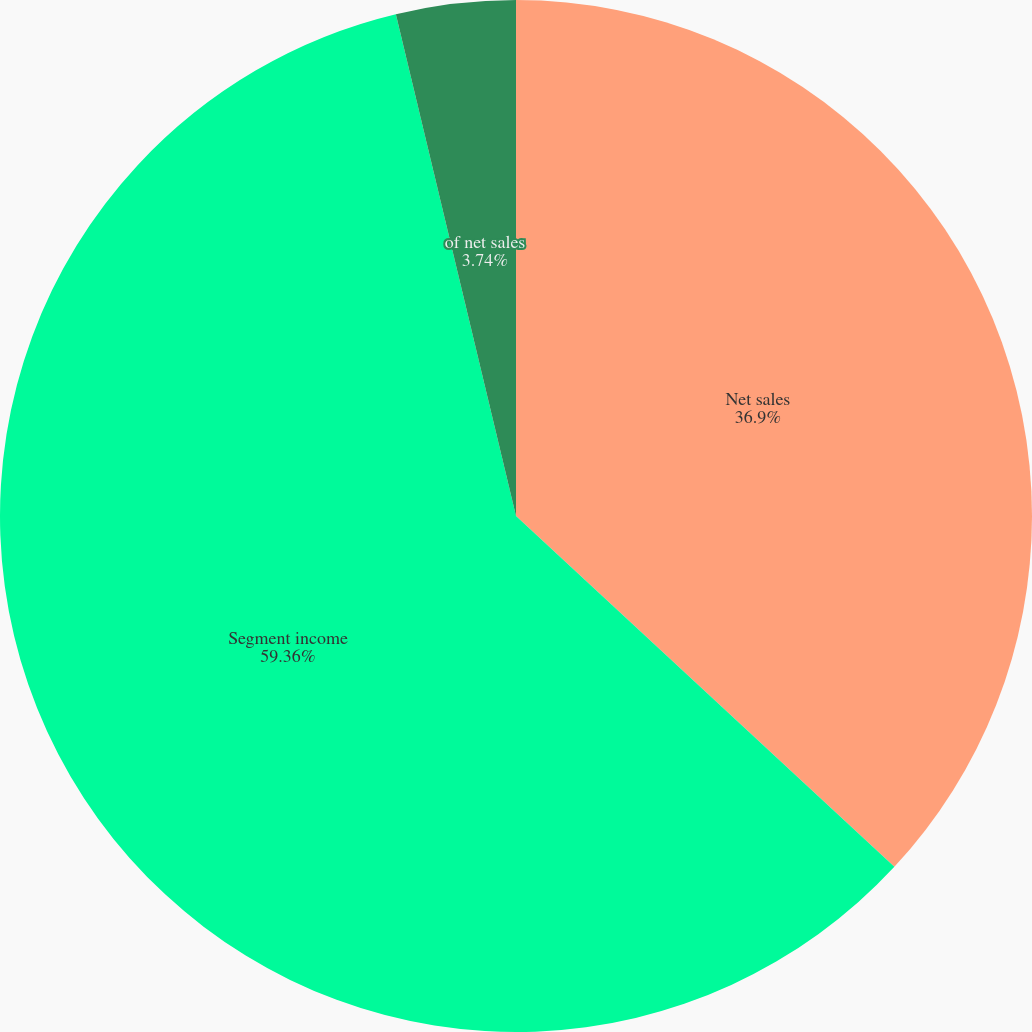Convert chart to OTSL. <chart><loc_0><loc_0><loc_500><loc_500><pie_chart><fcel>Net sales<fcel>Segment income<fcel>of net sales<nl><fcel>36.9%<fcel>59.36%<fcel>3.74%<nl></chart> 